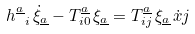<formula> <loc_0><loc_0><loc_500><loc_500>h _ { \ i } ^ { \underline { a } } \, \dot { \xi } _ { \underline { a } } - T _ { i 0 } ^ { \underline { a } } \, \xi _ { \underline { a } } = T _ { i j } ^ { \underline { a } } \, \xi _ { \underline { a } } \, { \dot { x } j }</formula> 